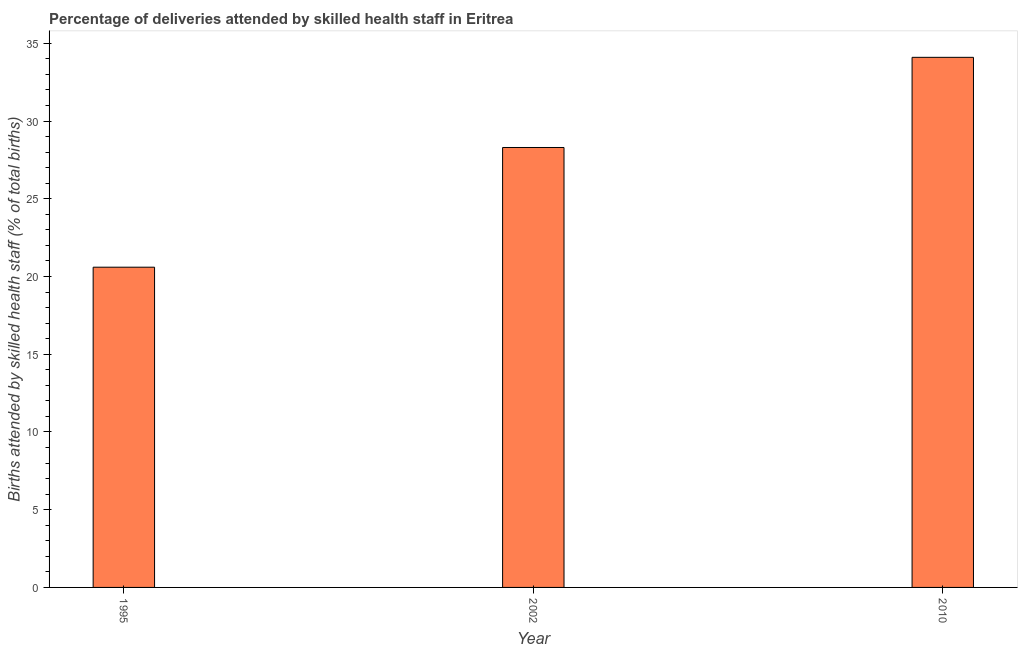Does the graph contain any zero values?
Your answer should be very brief. No. Does the graph contain grids?
Offer a very short reply. No. What is the title of the graph?
Your answer should be very brief. Percentage of deliveries attended by skilled health staff in Eritrea. What is the label or title of the Y-axis?
Make the answer very short. Births attended by skilled health staff (% of total births). What is the number of births attended by skilled health staff in 1995?
Offer a very short reply. 20.6. Across all years, what is the maximum number of births attended by skilled health staff?
Your answer should be very brief. 34.1. Across all years, what is the minimum number of births attended by skilled health staff?
Provide a short and direct response. 20.6. In which year was the number of births attended by skilled health staff maximum?
Ensure brevity in your answer.  2010. What is the sum of the number of births attended by skilled health staff?
Offer a terse response. 83. What is the difference between the number of births attended by skilled health staff in 1995 and 2002?
Your answer should be compact. -7.7. What is the average number of births attended by skilled health staff per year?
Your response must be concise. 27.67. What is the median number of births attended by skilled health staff?
Provide a succinct answer. 28.3. What is the ratio of the number of births attended by skilled health staff in 1995 to that in 2010?
Offer a terse response. 0.6. Is the number of births attended by skilled health staff in 1995 less than that in 2010?
Ensure brevity in your answer.  Yes. Is the difference between the number of births attended by skilled health staff in 1995 and 2002 greater than the difference between any two years?
Ensure brevity in your answer.  No. What is the difference between the highest and the second highest number of births attended by skilled health staff?
Make the answer very short. 5.8. What is the difference between the highest and the lowest number of births attended by skilled health staff?
Make the answer very short. 13.5. In how many years, is the number of births attended by skilled health staff greater than the average number of births attended by skilled health staff taken over all years?
Provide a short and direct response. 2. How many bars are there?
Keep it short and to the point. 3. Are all the bars in the graph horizontal?
Your response must be concise. No. Are the values on the major ticks of Y-axis written in scientific E-notation?
Offer a terse response. No. What is the Births attended by skilled health staff (% of total births) of 1995?
Keep it short and to the point. 20.6. What is the Births attended by skilled health staff (% of total births) of 2002?
Keep it short and to the point. 28.3. What is the Births attended by skilled health staff (% of total births) in 2010?
Provide a succinct answer. 34.1. What is the difference between the Births attended by skilled health staff (% of total births) in 1995 and 2010?
Ensure brevity in your answer.  -13.5. What is the difference between the Births attended by skilled health staff (% of total births) in 2002 and 2010?
Your answer should be compact. -5.8. What is the ratio of the Births attended by skilled health staff (% of total births) in 1995 to that in 2002?
Your answer should be compact. 0.73. What is the ratio of the Births attended by skilled health staff (% of total births) in 1995 to that in 2010?
Provide a short and direct response. 0.6. What is the ratio of the Births attended by skilled health staff (% of total births) in 2002 to that in 2010?
Your answer should be very brief. 0.83. 